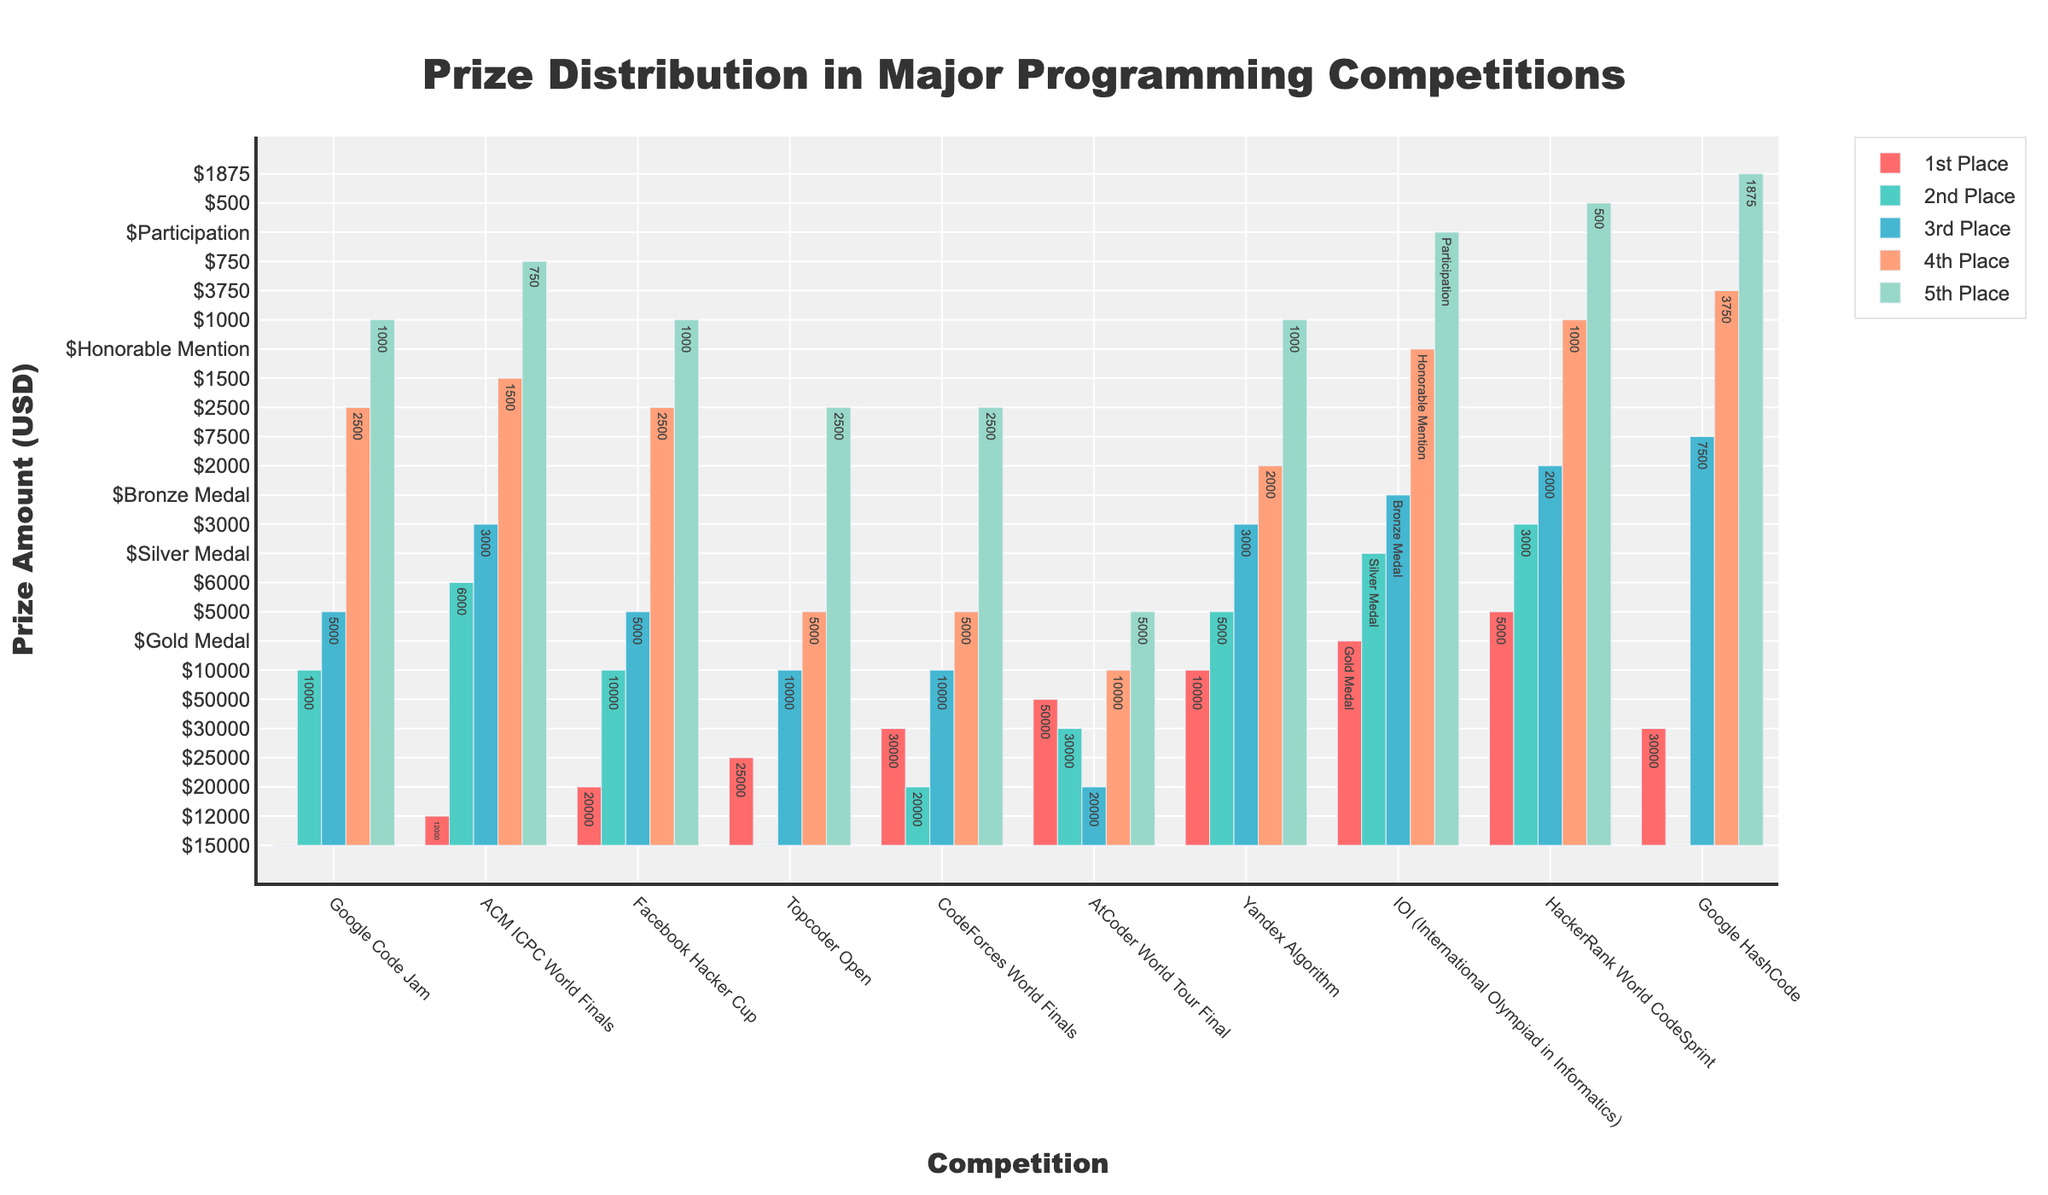What's the highest prize amount for any position? The highest prize can be determined by looking at the tallest bar in the chart for any position. Here, the tallest bar is for the 1st Place in the AtCoder World Tour Final, which is $50,000.
Answer: $50,000 Which competition has the lowest prize for 5th place? To determine the lowest prize for 5th Place, we look at the shortest bars in the 5th Place category across all competitions. The shortest bar for 5th Place is in the HackerRank World CodeSprint, with $500.
Answer: HackerRank World CodeSprint What's the difference between the 1st and 2nd place prizes in the AtCoder World Tour Final? The prize for the 1st Place in the AtCoder World Tour Final is $50,000, and for the 2nd Place, it is $30,000. The difference is calculated as $50,000 - $30,000 = $20,000.
Answer: $20,000 Which two competitions have the equal prize for 2nd place? We need to compare the heights of the bars for the 2nd Place prize in all competitions. The Google Code Jam and Facebook Hacker Cup both have a 2nd Place prize of $10,000.
Answer: Google Code Jam and Facebook Hacker Cup Which competition has the widest range of prize amounts from 1st to 5th place? The range is determined by subtracting the smallest prize amount from the largest prize amount within the same competition. The AtCoder World Tour Final has the widest range: $50,000 (1st) - $5,000 (5th) = $45,000.
Answer: AtCoder World Tour Final What's the total prize for the top 3 placements in Google Code Jam? Adding the prizes for the top 3 placements in Google Code Jam: $15,000 (1st) + $10,000 (2nd) + $5,000 (3rd) = $30,000.
Answer: $30,000 Compare the 3rd Place prize in Topcoder Open and CodeForces World Finals. Which one is higher? By comparing the heights of the bars, the 3rd Place prize in Topcoder Open is $10,000, whereas in CodeForces World Finals, it is also $10,000, so they are equal.
Answer: Equal How does the prize for 4th Place in Google HashCode compare to that in Topcoder Open? The prize for 4th Place in Google HashCode is $3,750, while that in Topcoder Open is $5,000. Hence, the prize in Topcoder Open is higher.
Answer: Topcoder Open Opposed to previous questions, consider which competition has the highest collective prize money for all top 5 placements? The sum of prizes for all top 5 placements is calculated for each competition. The AtCoder World Tour Final has the highest total: $50,000 + $30,000 + $20,000 + $10,000 + $5,000 = $115,000.
Answer: AtCoder World Tour Final Is the prize for 2nd place in the CodeForces World Finals more than double the prize for 4th place in the same competition? The prize for 2nd place in CodeForces World Finals is $20,000, and the prize for 4th place is $5,000. We check if $20,000 is more than double $5,000: $5,000 * 2 = $10,000. Since $20,000 > $10,000, the prize for 2nd place is indeed more than double.
Answer: Yes 